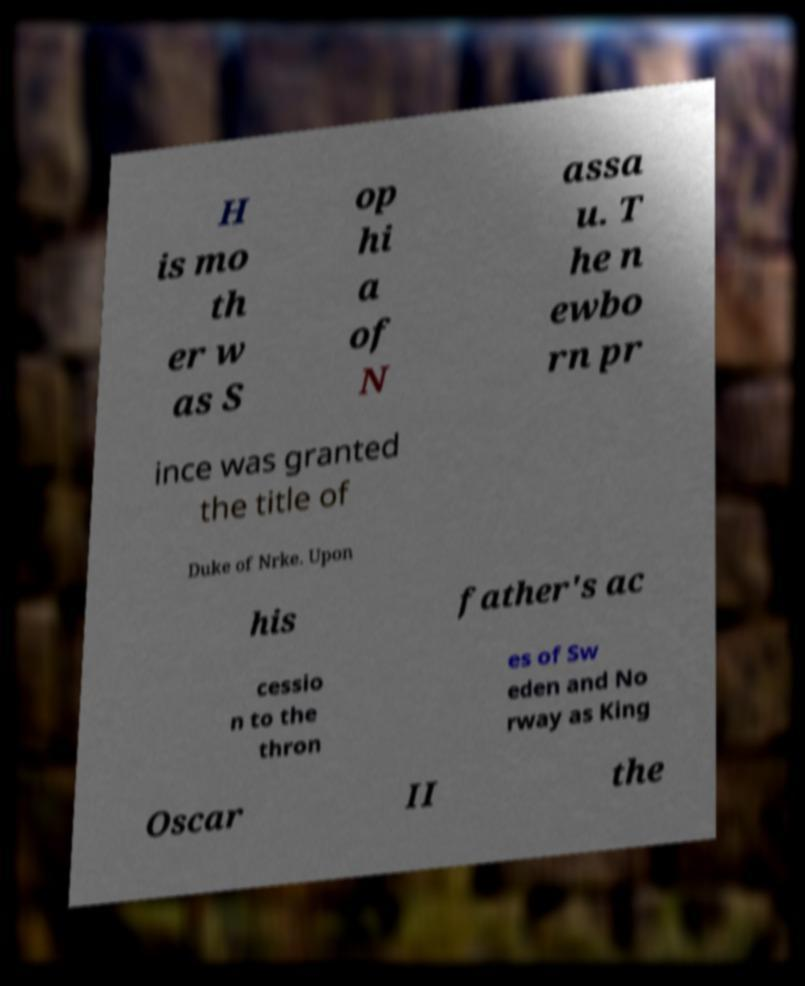What messages or text are displayed in this image? I need them in a readable, typed format. H is mo th er w as S op hi a of N assa u. T he n ewbo rn pr ince was granted the title of Duke of Nrke. Upon his father's ac cessio n to the thron es of Sw eden and No rway as King Oscar II the 